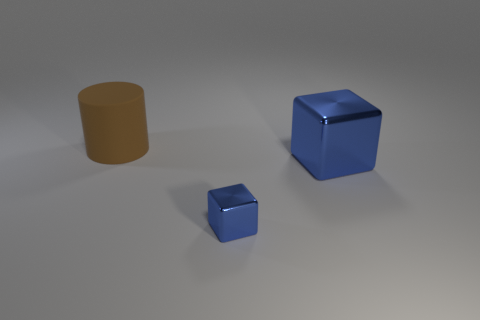What number of other objects are there of the same color as the small shiny object?
Make the answer very short. 1. How many shiny things are blue cubes or big blocks?
Give a very brief answer. 2. There is a big thing that is on the right side of the matte cylinder; is its color the same as the metal thing that is to the left of the big blue shiny block?
Make the answer very short. Yes. Are there any other things that have the same material as the cylinder?
Offer a terse response. No. There is another blue metallic thing that is the same shape as the small shiny object; what size is it?
Your answer should be compact. Large. Is the number of objects right of the big rubber object greater than the number of small blue shiny objects?
Provide a succinct answer. Yes. Does the blue object to the right of the small shiny block have the same material as the brown object?
Provide a succinct answer. No. There is a thing that is right of the blue metallic thing in front of the blue metal thing to the right of the small blue object; how big is it?
Ensure brevity in your answer.  Large. There is another thing that is made of the same material as the tiny blue thing; what size is it?
Provide a succinct answer. Large. There is a thing that is to the left of the big blue shiny object and in front of the rubber cylinder; what is its color?
Keep it short and to the point. Blue. 